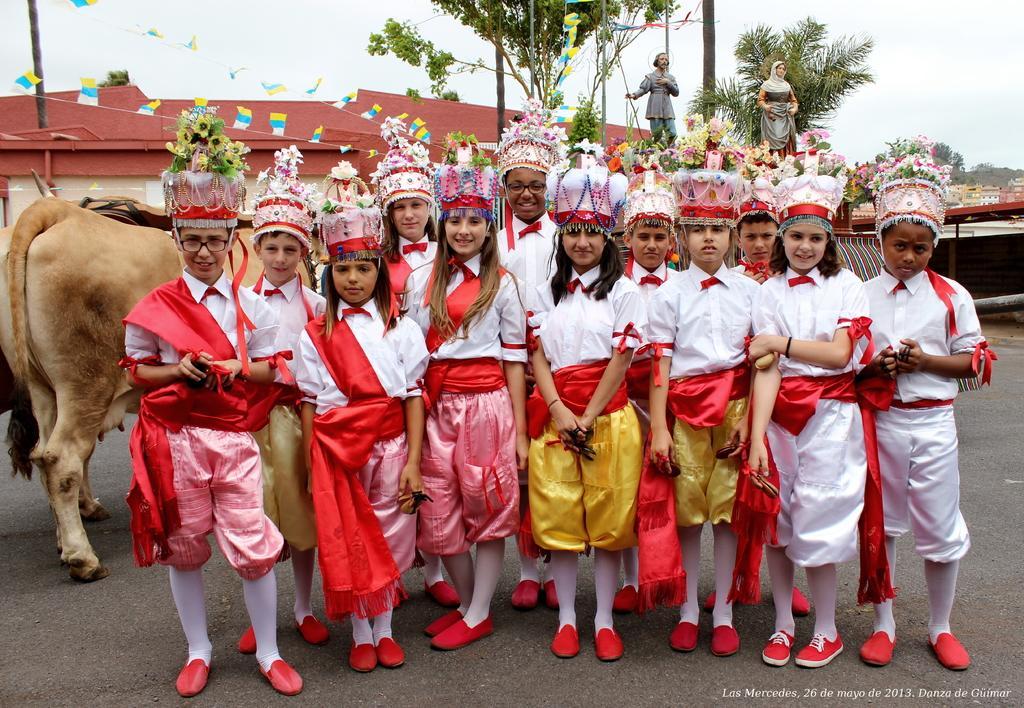Describe this image in one or two sentences. This is an outside view. Here I can see few children wearing costumes, standing on the road, smiling and giving pose for the picture. On the left side there is an animal. In the background there are few buildings, poles, trees and also I can see two statues of persons. At the top of the image I can see the sky. 